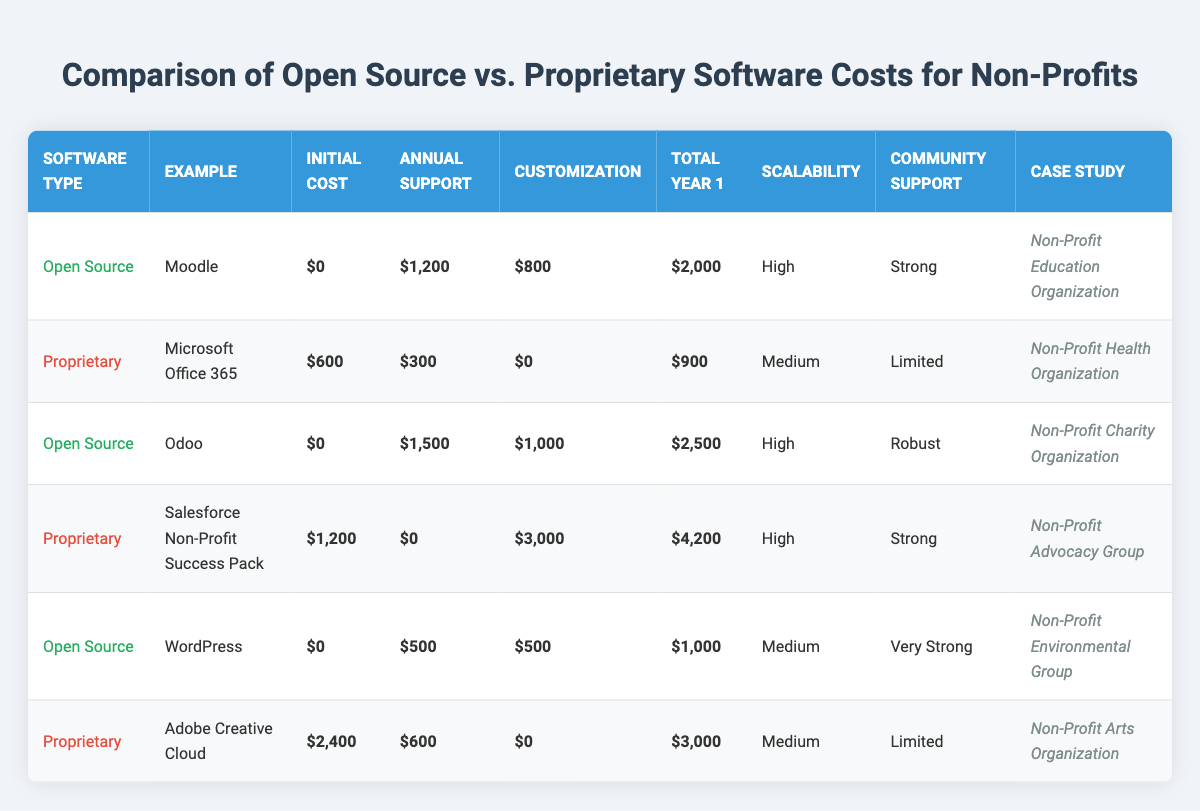What is the total year 1 cost for Moodle? The total year 1 cost for Moodle is listed in the table under 'Total Year 1' for Open Source, which is $2,000.
Answer: $2,000 Which proprietary software has the highest total year 1 cost? Looking at the total year 1 costs for proprietary software, Salesforce Non-Profit Success Pack has the highest cost at $4,200.
Answer: $4,200 What is the annual support cost for WordPress? The annual support cost for WordPress is found in the table under 'Annual Support' for Open Source, which is $500.
Answer: $500 Is the customization cost for Microsoft Office 365 greater than $500? The customization cost for Microsoft Office 365 is listed as $0, which is not greater than $500. Therefore, the answer is no.
Answer: No What is the average initial cost of the proprietary software? The initial costs for proprietary software are $600 (Microsoft Office 365), $1,200 (Salesforce), and $2,400 (Adobe Creative Cloud). Summing these gives $4,200. Dividing by the number of software (3), the average initial cost is $4,200 / 3 = $1,400.
Answer: $1,400 What is the total cost difference between Odoo and WordPress? The total year 1 cost for Odoo is $2,500 and for WordPress, it is $1,000. The difference is calculated as $2,500 - $1,000 = $1,500.
Answer: $1,500 Does Odoo have a higher annual support cost compared to Microsoft Office 365? The annual support cost for Odoo is $1,500 while for Microsoft Office 365 it is $300. Since $1,500 is greater than $300, the answer is yes.
Answer: Yes Which software type, Open Source or Proprietary, has lower average total year 1 costs? The total year 1 costs for Open Source (Moodle, Odoo, and WordPress) are $2,000, $2,500, and $1,000 respectively. Their average is ($2,000 + $2,500 + $1,000) / 3 = $1,833.33. For Proprietary (Microsoft Office 365, Salesforce, and Adobe) the costs are $900, $4,200, and $3,000. Their average is ($900 + $4,200 + $3,000) / 3 = $2,366.67. Hence, Open Source has lower average costs.
Answer: Open Source Which software example provides the strongest community support? Based on the 'Community Support' column in the table, WordPress has "Very Strong" community support, which is the highest rating among all examples.
Answer: WordPress 